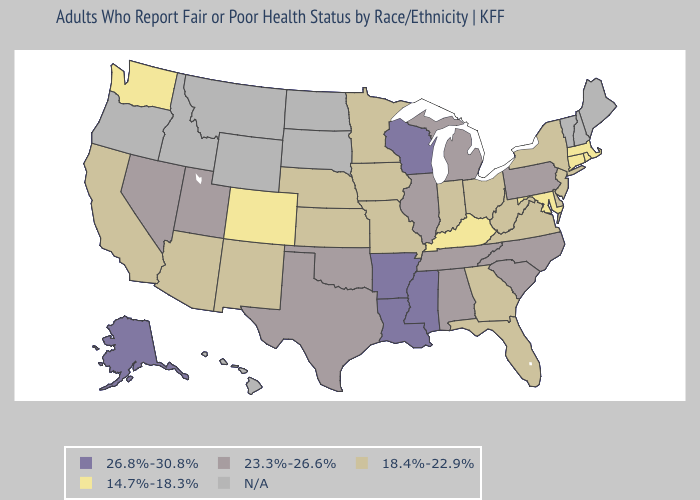What is the value of Illinois?
Short answer required. 23.3%-26.6%. Among the states that border Arizona , which have the lowest value?
Short answer required. Colorado. Does the map have missing data?
Write a very short answer. Yes. What is the value of South Dakota?
Answer briefly. N/A. Name the states that have a value in the range 14.7%-18.3%?
Short answer required. Colorado, Connecticut, Kentucky, Maryland, Massachusetts, Rhode Island, Washington. What is the value of Pennsylvania?
Keep it brief. 23.3%-26.6%. Name the states that have a value in the range 18.4%-22.9%?
Quick response, please. Arizona, California, Delaware, Florida, Georgia, Indiana, Iowa, Kansas, Minnesota, Missouri, Nebraska, New Jersey, New Mexico, New York, Ohio, Virginia, West Virginia. Which states hav the highest value in the Northeast?
Concise answer only. Pennsylvania. Name the states that have a value in the range 14.7%-18.3%?
Be succinct. Colorado, Connecticut, Kentucky, Maryland, Massachusetts, Rhode Island, Washington. Does the first symbol in the legend represent the smallest category?
Keep it brief. No. Name the states that have a value in the range 26.8%-30.8%?
Concise answer only. Alaska, Arkansas, Louisiana, Mississippi, Wisconsin. Name the states that have a value in the range N/A?
Be succinct. Hawaii, Idaho, Maine, Montana, New Hampshire, North Dakota, Oregon, South Dakota, Vermont, Wyoming. 